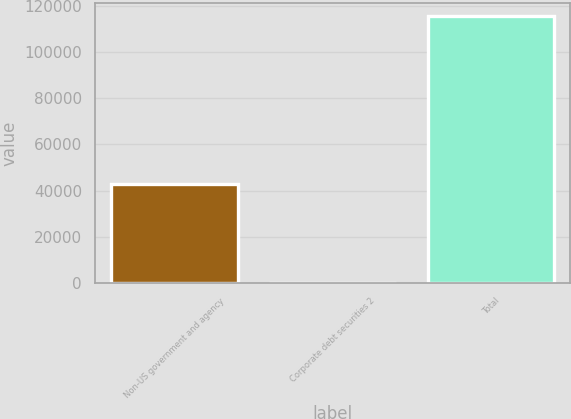Convert chart to OTSL. <chart><loc_0><loc_0><loc_500><loc_500><bar_chart><fcel>Non-US government and agency<fcel>Corporate debt securities 2<fcel>Total<nl><fcel>42854<fcel>133<fcel>115460<nl></chart> 